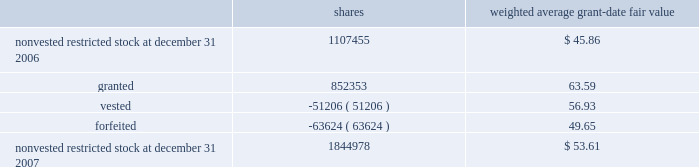Humana inc .
Notes to consolidated financial statements 2014 ( continued ) the total intrinsic value of stock options exercised during 2007 was $ 133.9 million , compared with $ 133.7 million during 2006 and $ 57.8 million during 2005 .
Cash received from stock option exercises for the years ended december 31 , 2007 , 2006 , and 2005 totaled $ 62.7 million , $ 49.2 million , and $ 36.4 million , respectively .
Total compensation expense related to nonvested options not yet recognized was $ 23.6 million at december 31 , 2007 .
We expect to recognize this compensation expense over a weighted average period of approximately 1.6 years .
Restricted stock awards restricted stock awards are granted with a fair value equal to the market price of our common stock on the date of grant .
Compensation expense is recorded straight-line over the vesting period , generally three years from the date of grant .
The weighted average grant date fair value of our restricted stock awards was $ 63.59 , $ 54.36 , and $ 32.81 for the years ended december 31 , 2007 , 2006 , and 2005 , respectively .
Activity for our restricted stock awards was as follows for the year ended december 31 , 2007 : shares weighted average grant-date fair value .
The fair value of shares vested during the years ended december 31 , 2007 , 2006 , and 2005 was $ 3.4 million , $ 2.3 million , and $ 0.6 million , respectively .
Total compensation expense related to nonvested restricted stock awards not yet recognized was $ 44.7 million at december 31 , 2007 .
We expect to recognize this compensation expense over a weighted average period of approximately 1.4 years .
There are no other contractual terms covering restricted stock awards once vested. .
What is the increase observed in the weighted average grant date fair value of the restricted stocks in 2006 and 2007? 
Rationale: it is the 2007 weighted average grant date fair value divided by the 2006's , then turned into a percentage to represent the increase .
Computations: ((63.59 / 54.36) - 1)
Answer: 0.16979. 